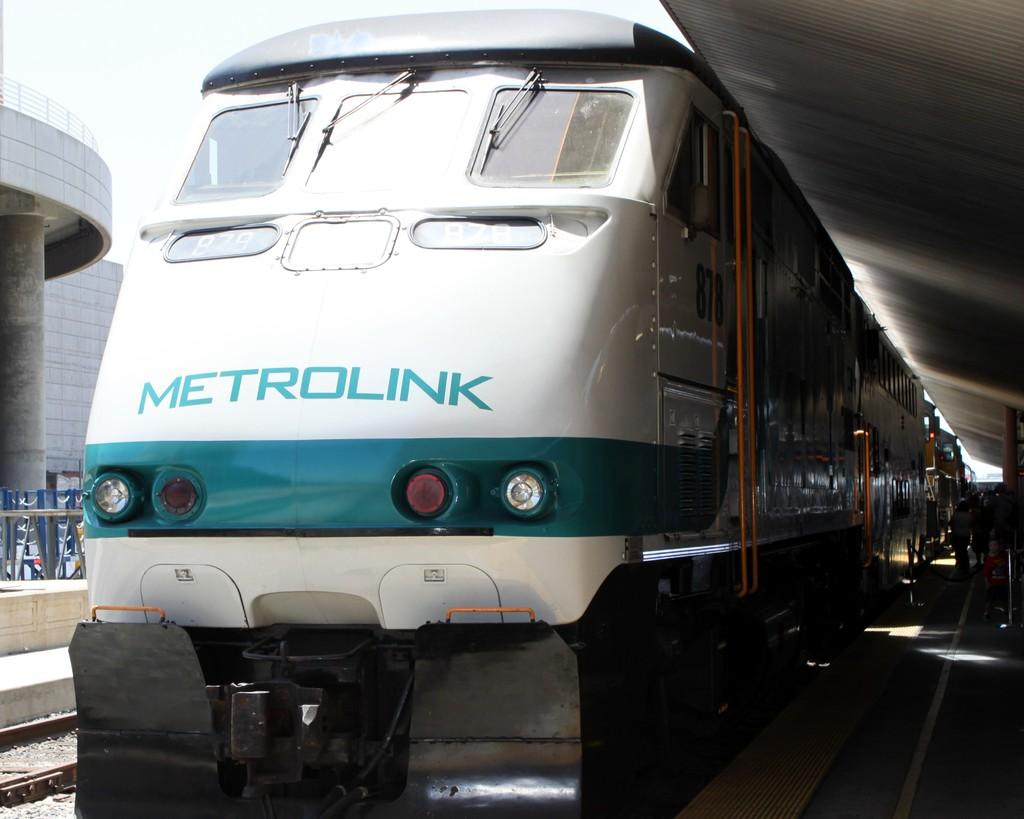What is the main subject of the image? The main subject of the image is a train. Where is the train located in the image? The train is located on a railway platform in the image. What is visible at the top of the image? The sky is visible at the top of the image. How many tubs are visible on the train in the image? There are no tubs present in the image; it features a train and a railway platform. What type of wire is connected to the train in the image? There is no wire connected to the train in the image; it is simply located on the railway platform. 